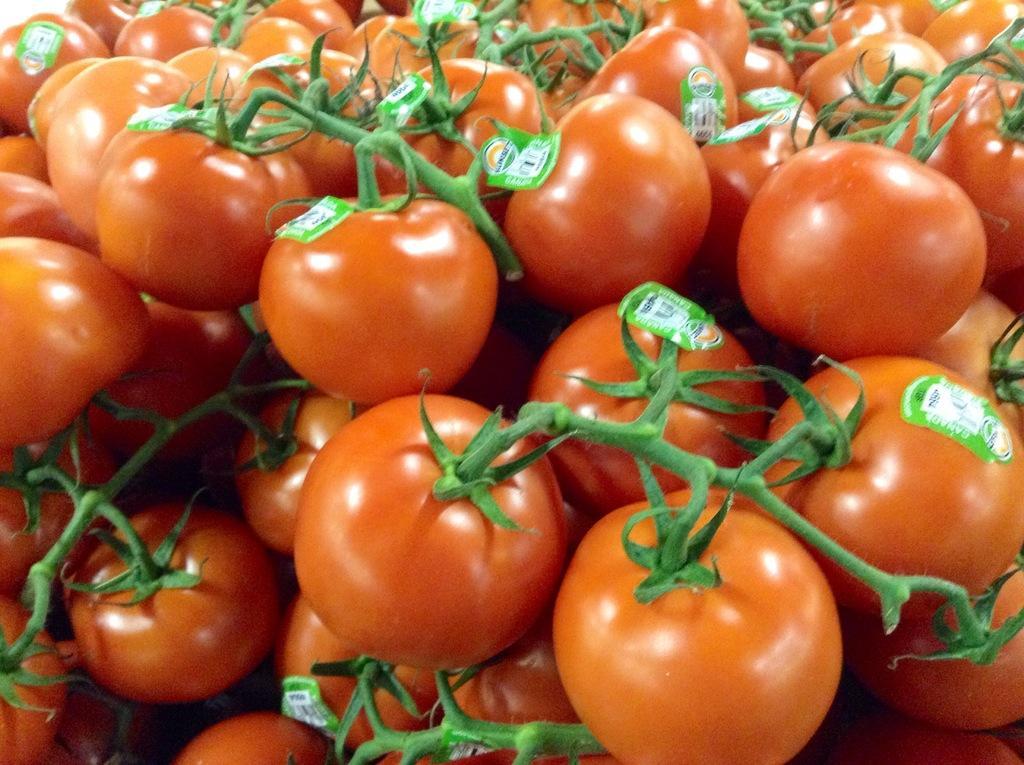In one or two sentences, can you explain what this image depicts? In this image we can see tomatoes and there are stickers on them. 